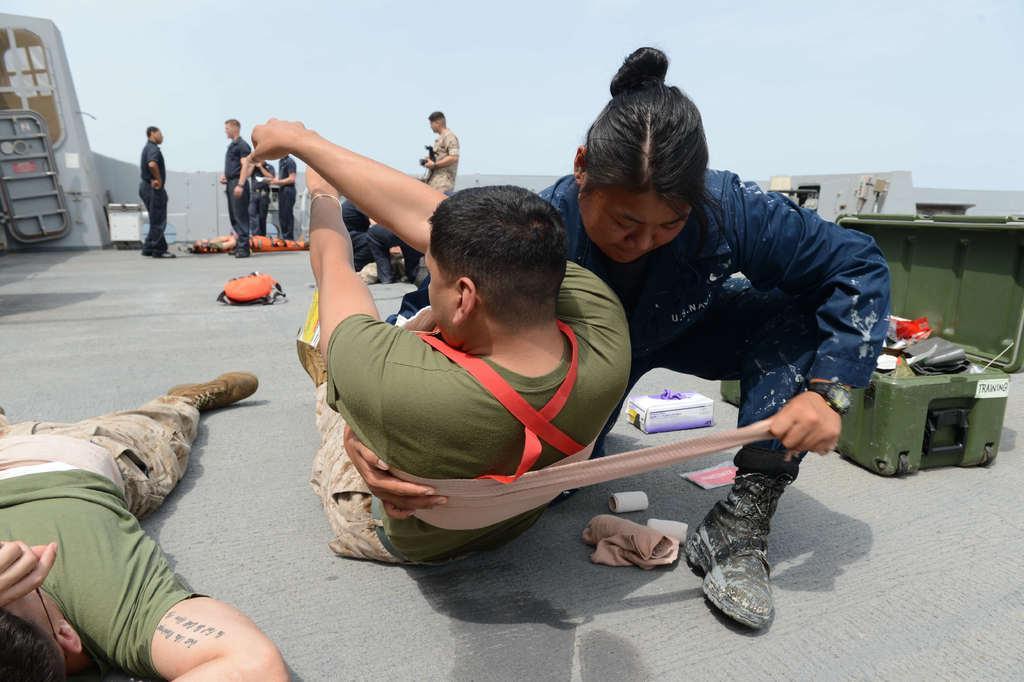In one or two sentences, can you explain what this image depicts? In the picture we can see a path to it, we can see a man lying and beside we can see another man lying and woman is holding him and tying a cloth to him and beside her we can see a box with some things in it and in the background, we can see some men are standing and one man is holding a gun and standing and behind them we can see a sky. 